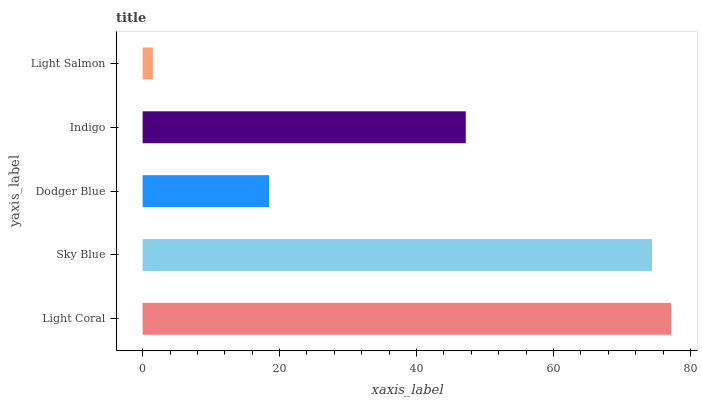Is Light Salmon the minimum?
Answer yes or no. Yes. Is Light Coral the maximum?
Answer yes or no. Yes. Is Sky Blue the minimum?
Answer yes or no. No. Is Sky Blue the maximum?
Answer yes or no. No. Is Light Coral greater than Sky Blue?
Answer yes or no. Yes. Is Sky Blue less than Light Coral?
Answer yes or no. Yes. Is Sky Blue greater than Light Coral?
Answer yes or no. No. Is Light Coral less than Sky Blue?
Answer yes or no. No. Is Indigo the high median?
Answer yes or no. Yes. Is Indigo the low median?
Answer yes or no. Yes. Is Sky Blue the high median?
Answer yes or no. No. Is Light Salmon the low median?
Answer yes or no. No. 